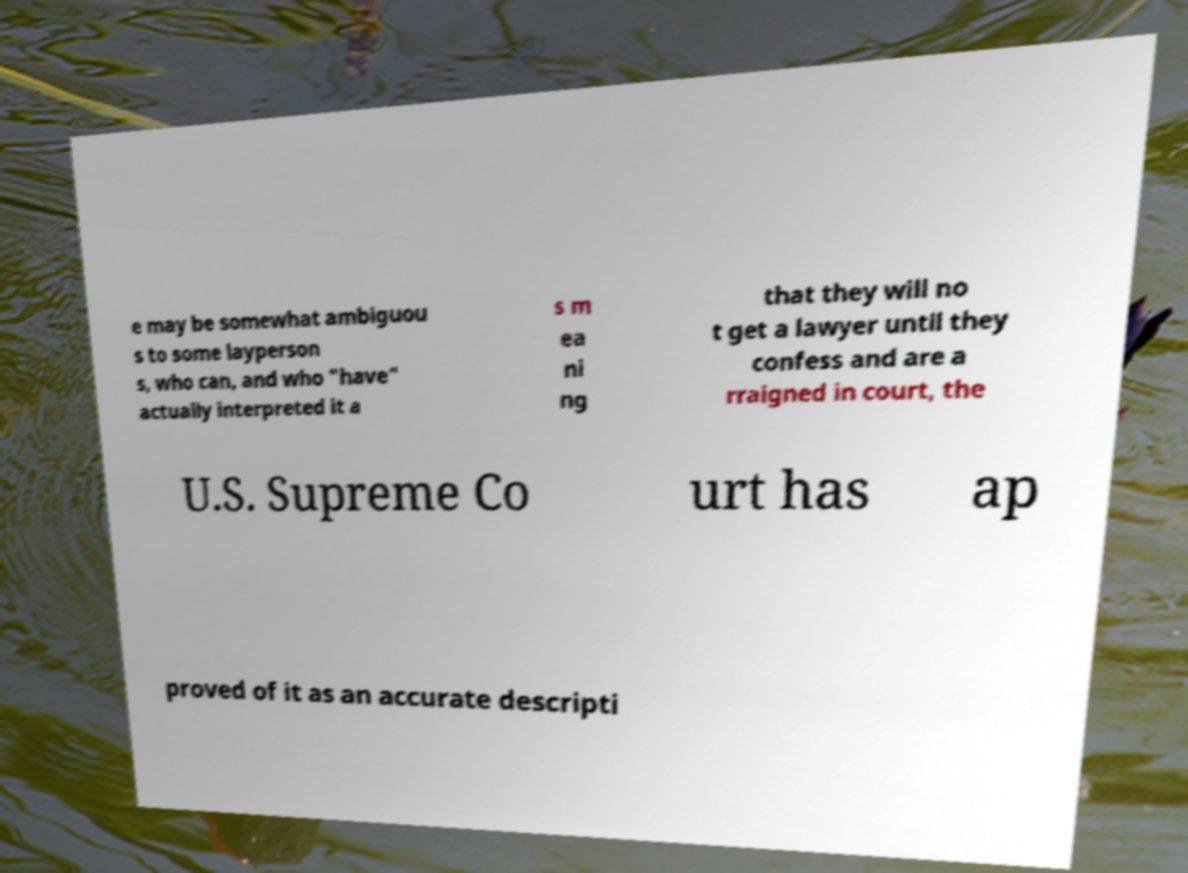Could you extract and type out the text from this image? e may be somewhat ambiguou s to some layperson s, who can, and who "have" actually interpreted it a s m ea ni ng that they will no t get a lawyer until they confess and are a rraigned in court, the U.S. Supreme Co urt has ap proved of it as an accurate descripti 